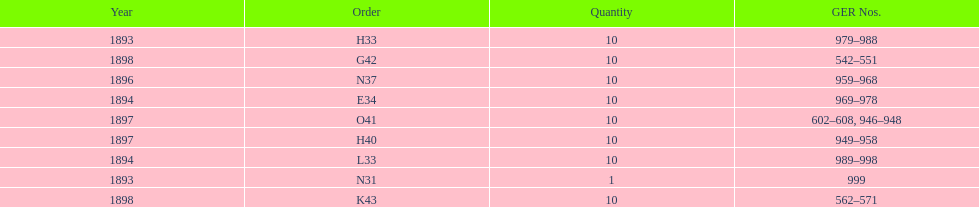What is the number of years with a quantity of 10? 5. 